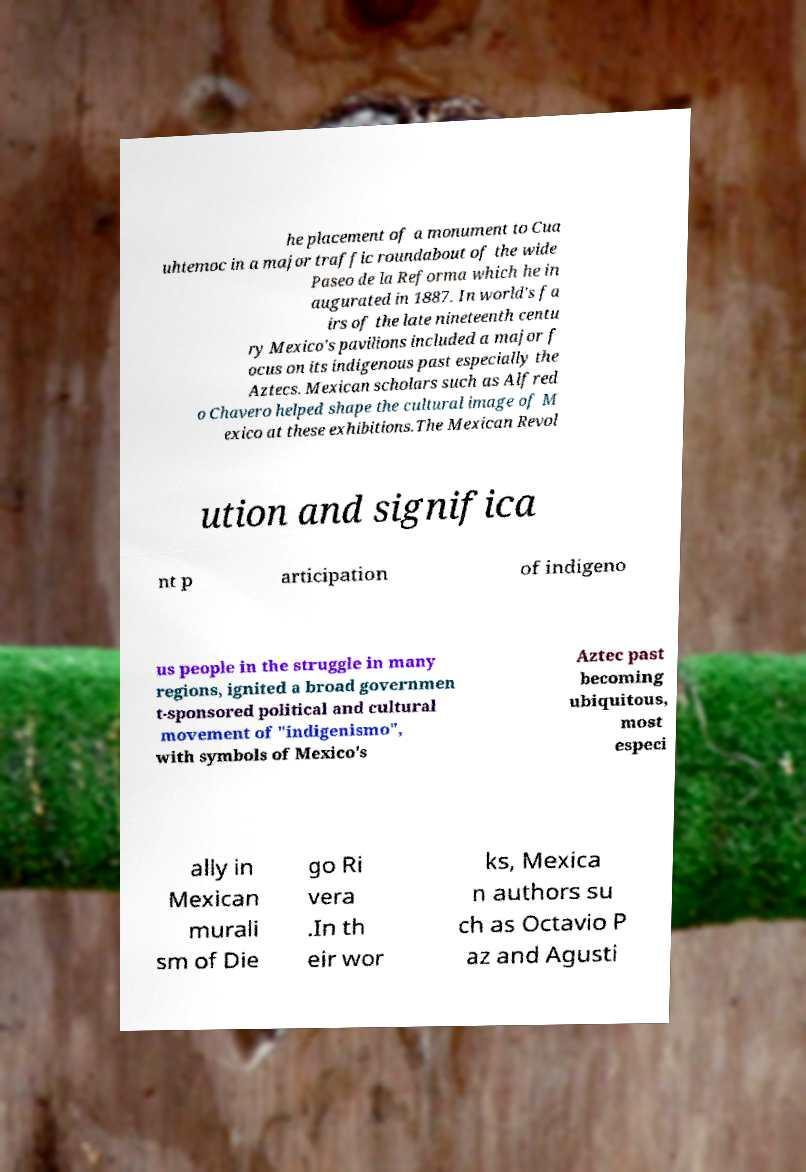Can you accurately transcribe the text from the provided image for me? he placement of a monument to Cua uhtemoc in a major traffic roundabout of the wide Paseo de la Reforma which he in augurated in 1887. In world's fa irs of the late nineteenth centu ry Mexico's pavilions included a major f ocus on its indigenous past especially the Aztecs. Mexican scholars such as Alfred o Chavero helped shape the cultural image of M exico at these exhibitions.The Mexican Revol ution and significa nt p articipation of indigeno us people in the struggle in many regions, ignited a broad governmen t-sponsored political and cultural movement of "indigenismo", with symbols of Mexico's Aztec past becoming ubiquitous, most especi ally in Mexican murali sm of Die go Ri vera .In th eir wor ks, Mexica n authors su ch as Octavio P az and Agusti 